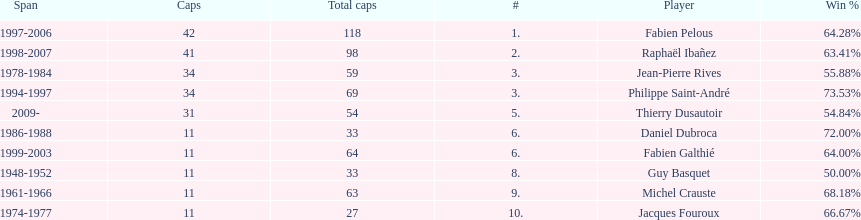Which captain served the least amount of time? Daniel Dubroca. 